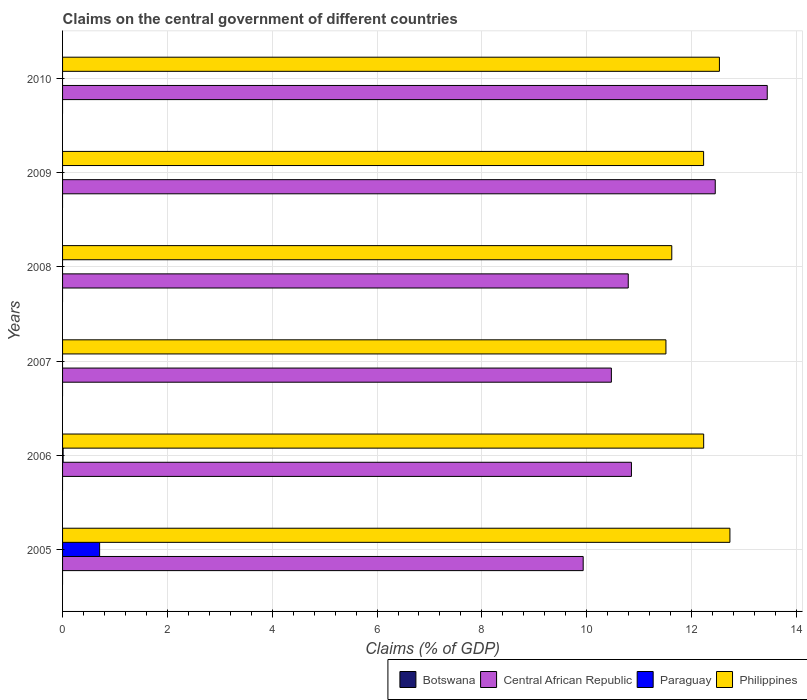How many groups of bars are there?
Keep it short and to the point. 6. Are the number of bars on each tick of the Y-axis equal?
Ensure brevity in your answer.  No. How many bars are there on the 2nd tick from the top?
Offer a very short reply. 2. Across all years, what is the maximum percentage of GDP claimed on the central government in Philippines?
Your response must be concise. 12.73. Across all years, what is the minimum percentage of GDP claimed on the central government in Philippines?
Your response must be concise. 11.51. In which year was the percentage of GDP claimed on the central government in Philippines maximum?
Make the answer very short. 2005. What is the total percentage of GDP claimed on the central government in Botswana in the graph?
Offer a very short reply. 0. What is the difference between the percentage of GDP claimed on the central government in Philippines in 2006 and that in 2008?
Offer a terse response. 0.61. What is the difference between the percentage of GDP claimed on the central government in Philippines in 2006 and the percentage of GDP claimed on the central government in Central African Republic in 2009?
Provide a short and direct response. -0.22. What is the average percentage of GDP claimed on the central government in Philippines per year?
Provide a succinct answer. 12.14. In the year 2005, what is the difference between the percentage of GDP claimed on the central government in Philippines and percentage of GDP claimed on the central government in Central African Republic?
Your answer should be compact. 2.8. Is the difference between the percentage of GDP claimed on the central government in Philippines in 2006 and 2007 greater than the difference between the percentage of GDP claimed on the central government in Central African Republic in 2006 and 2007?
Your answer should be very brief. Yes. What is the difference between the highest and the second highest percentage of GDP claimed on the central government in Central African Republic?
Provide a short and direct response. 0.99. What is the difference between the highest and the lowest percentage of GDP claimed on the central government in Philippines?
Your response must be concise. 1.22. In how many years, is the percentage of GDP claimed on the central government in Paraguay greater than the average percentage of GDP claimed on the central government in Paraguay taken over all years?
Make the answer very short. 1. Is the sum of the percentage of GDP claimed on the central government in Central African Republic in 2006 and 2007 greater than the maximum percentage of GDP claimed on the central government in Botswana across all years?
Offer a terse response. Yes. Is it the case that in every year, the sum of the percentage of GDP claimed on the central government in Central African Republic and percentage of GDP claimed on the central government in Paraguay is greater than the sum of percentage of GDP claimed on the central government in Botswana and percentage of GDP claimed on the central government in Philippines?
Offer a terse response. No. Is it the case that in every year, the sum of the percentage of GDP claimed on the central government in Botswana and percentage of GDP claimed on the central government in Central African Republic is greater than the percentage of GDP claimed on the central government in Philippines?
Give a very brief answer. No. How many bars are there?
Your response must be concise. 14. How many years are there in the graph?
Provide a short and direct response. 6. What is the difference between two consecutive major ticks on the X-axis?
Your answer should be compact. 2. Are the values on the major ticks of X-axis written in scientific E-notation?
Your answer should be very brief. No. Does the graph contain grids?
Your answer should be very brief. Yes. How many legend labels are there?
Make the answer very short. 4. How are the legend labels stacked?
Your response must be concise. Horizontal. What is the title of the graph?
Make the answer very short. Claims on the central government of different countries. Does "Northern Mariana Islands" appear as one of the legend labels in the graph?
Your answer should be compact. No. What is the label or title of the X-axis?
Ensure brevity in your answer.  Claims (% of GDP). What is the label or title of the Y-axis?
Provide a succinct answer. Years. What is the Claims (% of GDP) of Botswana in 2005?
Your answer should be very brief. 0. What is the Claims (% of GDP) of Central African Republic in 2005?
Keep it short and to the point. 9.93. What is the Claims (% of GDP) in Paraguay in 2005?
Your answer should be very brief. 0.71. What is the Claims (% of GDP) of Philippines in 2005?
Ensure brevity in your answer.  12.73. What is the Claims (% of GDP) in Central African Republic in 2006?
Offer a terse response. 10.85. What is the Claims (% of GDP) in Paraguay in 2006?
Ensure brevity in your answer.  0.01. What is the Claims (% of GDP) of Philippines in 2006?
Keep it short and to the point. 12.23. What is the Claims (% of GDP) in Botswana in 2007?
Give a very brief answer. 0. What is the Claims (% of GDP) of Central African Republic in 2007?
Offer a very short reply. 10.47. What is the Claims (% of GDP) in Paraguay in 2007?
Make the answer very short. 0. What is the Claims (% of GDP) of Philippines in 2007?
Ensure brevity in your answer.  11.51. What is the Claims (% of GDP) of Central African Republic in 2008?
Your answer should be compact. 10.79. What is the Claims (% of GDP) of Philippines in 2008?
Offer a terse response. 11.62. What is the Claims (% of GDP) of Central African Republic in 2009?
Provide a succinct answer. 12.45. What is the Claims (% of GDP) of Paraguay in 2009?
Your response must be concise. 0. What is the Claims (% of GDP) of Philippines in 2009?
Provide a succinct answer. 12.23. What is the Claims (% of GDP) of Botswana in 2010?
Keep it short and to the point. 0. What is the Claims (% of GDP) in Central African Republic in 2010?
Keep it short and to the point. 13.45. What is the Claims (% of GDP) of Philippines in 2010?
Your answer should be compact. 12.53. Across all years, what is the maximum Claims (% of GDP) of Central African Republic?
Give a very brief answer. 13.45. Across all years, what is the maximum Claims (% of GDP) of Paraguay?
Give a very brief answer. 0.71. Across all years, what is the maximum Claims (% of GDP) of Philippines?
Your answer should be very brief. 12.73. Across all years, what is the minimum Claims (% of GDP) of Central African Republic?
Your response must be concise. 9.93. Across all years, what is the minimum Claims (% of GDP) in Philippines?
Your response must be concise. 11.51. What is the total Claims (% of GDP) of Botswana in the graph?
Your answer should be very brief. 0. What is the total Claims (% of GDP) in Central African Republic in the graph?
Offer a very short reply. 67.95. What is the total Claims (% of GDP) of Paraguay in the graph?
Provide a short and direct response. 0.72. What is the total Claims (% of GDP) in Philippines in the graph?
Give a very brief answer. 72.87. What is the difference between the Claims (% of GDP) of Central African Republic in 2005 and that in 2006?
Ensure brevity in your answer.  -0.92. What is the difference between the Claims (% of GDP) in Paraguay in 2005 and that in 2006?
Your answer should be compact. 0.7. What is the difference between the Claims (% of GDP) of Philippines in 2005 and that in 2006?
Offer a terse response. 0.5. What is the difference between the Claims (% of GDP) in Central African Republic in 2005 and that in 2007?
Your answer should be very brief. -0.54. What is the difference between the Claims (% of GDP) of Philippines in 2005 and that in 2007?
Your answer should be compact. 1.22. What is the difference between the Claims (% of GDP) in Central African Republic in 2005 and that in 2008?
Ensure brevity in your answer.  -0.86. What is the difference between the Claims (% of GDP) in Philippines in 2005 and that in 2008?
Give a very brief answer. 1.11. What is the difference between the Claims (% of GDP) in Central African Republic in 2005 and that in 2009?
Offer a very short reply. -2.52. What is the difference between the Claims (% of GDP) of Philippines in 2005 and that in 2009?
Offer a terse response. 0.5. What is the difference between the Claims (% of GDP) of Central African Republic in 2005 and that in 2010?
Your response must be concise. -3.51. What is the difference between the Claims (% of GDP) of Philippines in 2005 and that in 2010?
Give a very brief answer. 0.2. What is the difference between the Claims (% of GDP) of Central African Republic in 2006 and that in 2007?
Keep it short and to the point. 0.38. What is the difference between the Claims (% of GDP) in Philippines in 2006 and that in 2007?
Give a very brief answer. 0.72. What is the difference between the Claims (% of GDP) in Central African Republic in 2006 and that in 2008?
Keep it short and to the point. 0.06. What is the difference between the Claims (% of GDP) in Philippines in 2006 and that in 2008?
Keep it short and to the point. 0.61. What is the difference between the Claims (% of GDP) in Central African Republic in 2006 and that in 2009?
Your response must be concise. -1.6. What is the difference between the Claims (% of GDP) of Philippines in 2006 and that in 2009?
Your response must be concise. 0. What is the difference between the Claims (% of GDP) of Central African Republic in 2006 and that in 2010?
Provide a short and direct response. -2.59. What is the difference between the Claims (% of GDP) in Philippines in 2006 and that in 2010?
Give a very brief answer. -0.3. What is the difference between the Claims (% of GDP) of Central African Republic in 2007 and that in 2008?
Your answer should be very brief. -0.32. What is the difference between the Claims (% of GDP) in Philippines in 2007 and that in 2008?
Make the answer very short. -0.11. What is the difference between the Claims (% of GDP) in Central African Republic in 2007 and that in 2009?
Ensure brevity in your answer.  -1.98. What is the difference between the Claims (% of GDP) in Philippines in 2007 and that in 2009?
Offer a terse response. -0.72. What is the difference between the Claims (% of GDP) in Central African Republic in 2007 and that in 2010?
Offer a very short reply. -2.97. What is the difference between the Claims (% of GDP) in Philippines in 2007 and that in 2010?
Your answer should be very brief. -1.02. What is the difference between the Claims (% of GDP) in Central African Republic in 2008 and that in 2009?
Ensure brevity in your answer.  -1.66. What is the difference between the Claims (% of GDP) of Philippines in 2008 and that in 2009?
Provide a short and direct response. -0.61. What is the difference between the Claims (% of GDP) of Central African Republic in 2008 and that in 2010?
Give a very brief answer. -2.65. What is the difference between the Claims (% of GDP) of Philippines in 2008 and that in 2010?
Your answer should be compact. -0.91. What is the difference between the Claims (% of GDP) of Central African Republic in 2009 and that in 2010?
Offer a very short reply. -0.99. What is the difference between the Claims (% of GDP) in Philippines in 2009 and that in 2010?
Offer a very short reply. -0.3. What is the difference between the Claims (% of GDP) of Central African Republic in 2005 and the Claims (% of GDP) of Paraguay in 2006?
Give a very brief answer. 9.92. What is the difference between the Claims (% of GDP) of Central African Republic in 2005 and the Claims (% of GDP) of Philippines in 2006?
Offer a very short reply. -2.3. What is the difference between the Claims (% of GDP) in Paraguay in 2005 and the Claims (% of GDP) in Philippines in 2006?
Make the answer very short. -11.53. What is the difference between the Claims (% of GDP) of Central African Republic in 2005 and the Claims (% of GDP) of Philippines in 2007?
Ensure brevity in your answer.  -1.58. What is the difference between the Claims (% of GDP) of Paraguay in 2005 and the Claims (% of GDP) of Philippines in 2007?
Your answer should be compact. -10.81. What is the difference between the Claims (% of GDP) in Central African Republic in 2005 and the Claims (% of GDP) in Philippines in 2008?
Keep it short and to the point. -1.69. What is the difference between the Claims (% of GDP) in Paraguay in 2005 and the Claims (% of GDP) in Philippines in 2008?
Give a very brief answer. -10.92. What is the difference between the Claims (% of GDP) in Central African Republic in 2005 and the Claims (% of GDP) in Philippines in 2009?
Your response must be concise. -2.3. What is the difference between the Claims (% of GDP) of Paraguay in 2005 and the Claims (% of GDP) of Philippines in 2009?
Make the answer very short. -11.52. What is the difference between the Claims (% of GDP) of Central African Republic in 2005 and the Claims (% of GDP) of Philippines in 2010?
Offer a very short reply. -2.6. What is the difference between the Claims (% of GDP) of Paraguay in 2005 and the Claims (% of GDP) of Philippines in 2010?
Your answer should be very brief. -11.83. What is the difference between the Claims (% of GDP) in Central African Republic in 2006 and the Claims (% of GDP) in Philippines in 2007?
Give a very brief answer. -0.66. What is the difference between the Claims (% of GDP) in Paraguay in 2006 and the Claims (% of GDP) in Philippines in 2007?
Provide a succinct answer. -11.5. What is the difference between the Claims (% of GDP) in Central African Republic in 2006 and the Claims (% of GDP) in Philippines in 2008?
Your response must be concise. -0.77. What is the difference between the Claims (% of GDP) in Paraguay in 2006 and the Claims (% of GDP) in Philippines in 2008?
Provide a succinct answer. -11.61. What is the difference between the Claims (% of GDP) of Central African Republic in 2006 and the Claims (% of GDP) of Philippines in 2009?
Offer a terse response. -1.38. What is the difference between the Claims (% of GDP) of Paraguay in 2006 and the Claims (% of GDP) of Philippines in 2009?
Offer a very short reply. -12.22. What is the difference between the Claims (% of GDP) in Central African Republic in 2006 and the Claims (% of GDP) in Philippines in 2010?
Your answer should be compact. -1.68. What is the difference between the Claims (% of GDP) in Paraguay in 2006 and the Claims (% of GDP) in Philippines in 2010?
Give a very brief answer. -12.52. What is the difference between the Claims (% of GDP) of Central African Republic in 2007 and the Claims (% of GDP) of Philippines in 2008?
Provide a short and direct response. -1.15. What is the difference between the Claims (% of GDP) in Central African Republic in 2007 and the Claims (% of GDP) in Philippines in 2009?
Offer a terse response. -1.76. What is the difference between the Claims (% of GDP) of Central African Republic in 2007 and the Claims (% of GDP) of Philippines in 2010?
Provide a short and direct response. -2.06. What is the difference between the Claims (% of GDP) in Central African Republic in 2008 and the Claims (% of GDP) in Philippines in 2009?
Your response must be concise. -1.44. What is the difference between the Claims (% of GDP) in Central African Republic in 2008 and the Claims (% of GDP) in Philippines in 2010?
Give a very brief answer. -1.74. What is the difference between the Claims (% of GDP) in Central African Republic in 2009 and the Claims (% of GDP) in Philippines in 2010?
Offer a terse response. -0.08. What is the average Claims (% of GDP) of Central African Republic per year?
Your answer should be very brief. 11.33. What is the average Claims (% of GDP) of Paraguay per year?
Keep it short and to the point. 0.12. What is the average Claims (% of GDP) of Philippines per year?
Ensure brevity in your answer.  12.14. In the year 2005, what is the difference between the Claims (% of GDP) of Central African Republic and Claims (% of GDP) of Paraguay?
Ensure brevity in your answer.  9.23. In the year 2005, what is the difference between the Claims (% of GDP) in Central African Republic and Claims (% of GDP) in Philippines?
Keep it short and to the point. -2.8. In the year 2005, what is the difference between the Claims (% of GDP) in Paraguay and Claims (% of GDP) in Philippines?
Offer a very short reply. -12.03. In the year 2006, what is the difference between the Claims (% of GDP) of Central African Republic and Claims (% of GDP) of Paraguay?
Provide a short and direct response. 10.84. In the year 2006, what is the difference between the Claims (% of GDP) in Central African Republic and Claims (% of GDP) in Philippines?
Make the answer very short. -1.38. In the year 2006, what is the difference between the Claims (% of GDP) of Paraguay and Claims (% of GDP) of Philippines?
Make the answer very short. -12.22. In the year 2007, what is the difference between the Claims (% of GDP) of Central African Republic and Claims (% of GDP) of Philippines?
Provide a succinct answer. -1.04. In the year 2008, what is the difference between the Claims (% of GDP) in Central African Republic and Claims (% of GDP) in Philippines?
Offer a terse response. -0.83. In the year 2009, what is the difference between the Claims (% of GDP) of Central African Republic and Claims (% of GDP) of Philippines?
Your response must be concise. 0.22. In the year 2010, what is the difference between the Claims (% of GDP) of Central African Republic and Claims (% of GDP) of Philippines?
Offer a very short reply. 0.91. What is the ratio of the Claims (% of GDP) of Central African Republic in 2005 to that in 2006?
Make the answer very short. 0.92. What is the ratio of the Claims (% of GDP) of Paraguay in 2005 to that in 2006?
Ensure brevity in your answer.  66.2. What is the ratio of the Claims (% of GDP) of Philippines in 2005 to that in 2006?
Your answer should be compact. 1.04. What is the ratio of the Claims (% of GDP) in Central African Republic in 2005 to that in 2007?
Your response must be concise. 0.95. What is the ratio of the Claims (% of GDP) in Philippines in 2005 to that in 2007?
Your answer should be very brief. 1.11. What is the ratio of the Claims (% of GDP) of Central African Republic in 2005 to that in 2008?
Provide a short and direct response. 0.92. What is the ratio of the Claims (% of GDP) of Philippines in 2005 to that in 2008?
Your answer should be compact. 1.1. What is the ratio of the Claims (% of GDP) in Central African Republic in 2005 to that in 2009?
Your answer should be compact. 0.8. What is the ratio of the Claims (% of GDP) in Philippines in 2005 to that in 2009?
Make the answer very short. 1.04. What is the ratio of the Claims (% of GDP) of Central African Republic in 2005 to that in 2010?
Your answer should be compact. 0.74. What is the ratio of the Claims (% of GDP) of Philippines in 2005 to that in 2010?
Give a very brief answer. 1.02. What is the ratio of the Claims (% of GDP) in Central African Republic in 2006 to that in 2007?
Provide a succinct answer. 1.04. What is the ratio of the Claims (% of GDP) in Philippines in 2006 to that in 2007?
Provide a short and direct response. 1.06. What is the ratio of the Claims (% of GDP) of Central African Republic in 2006 to that in 2008?
Give a very brief answer. 1.01. What is the ratio of the Claims (% of GDP) of Philippines in 2006 to that in 2008?
Make the answer very short. 1.05. What is the ratio of the Claims (% of GDP) of Central African Republic in 2006 to that in 2009?
Provide a succinct answer. 0.87. What is the ratio of the Claims (% of GDP) of Central African Republic in 2006 to that in 2010?
Your answer should be very brief. 0.81. What is the ratio of the Claims (% of GDP) in Philippines in 2006 to that in 2010?
Make the answer very short. 0.98. What is the ratio of the Claims (% of GDP) in Central African Republic in 2007 to that in 2008?
Give a very brief answer. 0.97. What is the ratio of the Claims (% of GDP) of Philippines in 2007 to that in 2008?
Offer a terse response. 0.99. What is the ratio of the Claims (% of GDP) in Central African Republic in 2007 to that in 2009?
Your answer should be compact. 0.84. What is the ratio of the Claims (% of GDP) in Central African Republic in 2007 to that in 2010?
Provide a succinct answer. 0.78. What is the ratio of the Claims (% of GDP) in Philippines in 2007 to that in 2010?
Your answer should be very brief. 0.92. What is the ratio of the Claims (% of GDP) of Central African Republic in 2008 to that in 2009?
Offer a terse response. 0.87. What is the ratio of the Claims (% of GDP) of Philippines in 2008 to that in 2009?
Your response must be concise. 0.95. What is the ratio of the Claims (% of GDP) of Central African Republic in 2008 to that in 2010?
Your answer should be compact. 0.8. What is the ratio of the Claims (% of GDP) of Philippines in 2008 to that in 2010?
Provide a short and direct response. 0.93. What is the ratio of the Claims (% of GDP) in Central African Republic in 2009 to that in 2010?
Provide a short and direct response. 0.93. What is the ratio of the Claims (% of GDP) of Philippines in 2009 to that in 2010?
Provide a short and direct response. 0.98. What is the difference between the highest and the second highest Claims (% of GDP) in Central African Republic?
Provide a succinct answer. 0.99. What is the difference between the highest and the second highest Claims (% of GDP) in Philippines?
Make the answer very short. 0.2. What is the difference between the highest and the lowest Claims (% of GDP) of Central African Republic?
Make the answer very short. 3.51. What is the difference between the highest and the lowest Claims (% of GDP) of Paraguay?
Make the answer very short. 0.71. What is the difference between the highest and the lowest Claims (% of GDP) in Philippines?
Provide a short and direct response. 1.22. 